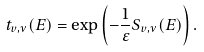<formula> <loc_0><loc_0><loc_500><loc_500>t _ { v , \nu } ( E ) = \exp \left ( - \frac { 1 } { \varepsilon } S _ { v , \nu } ( E ) \right ) .</formula> 